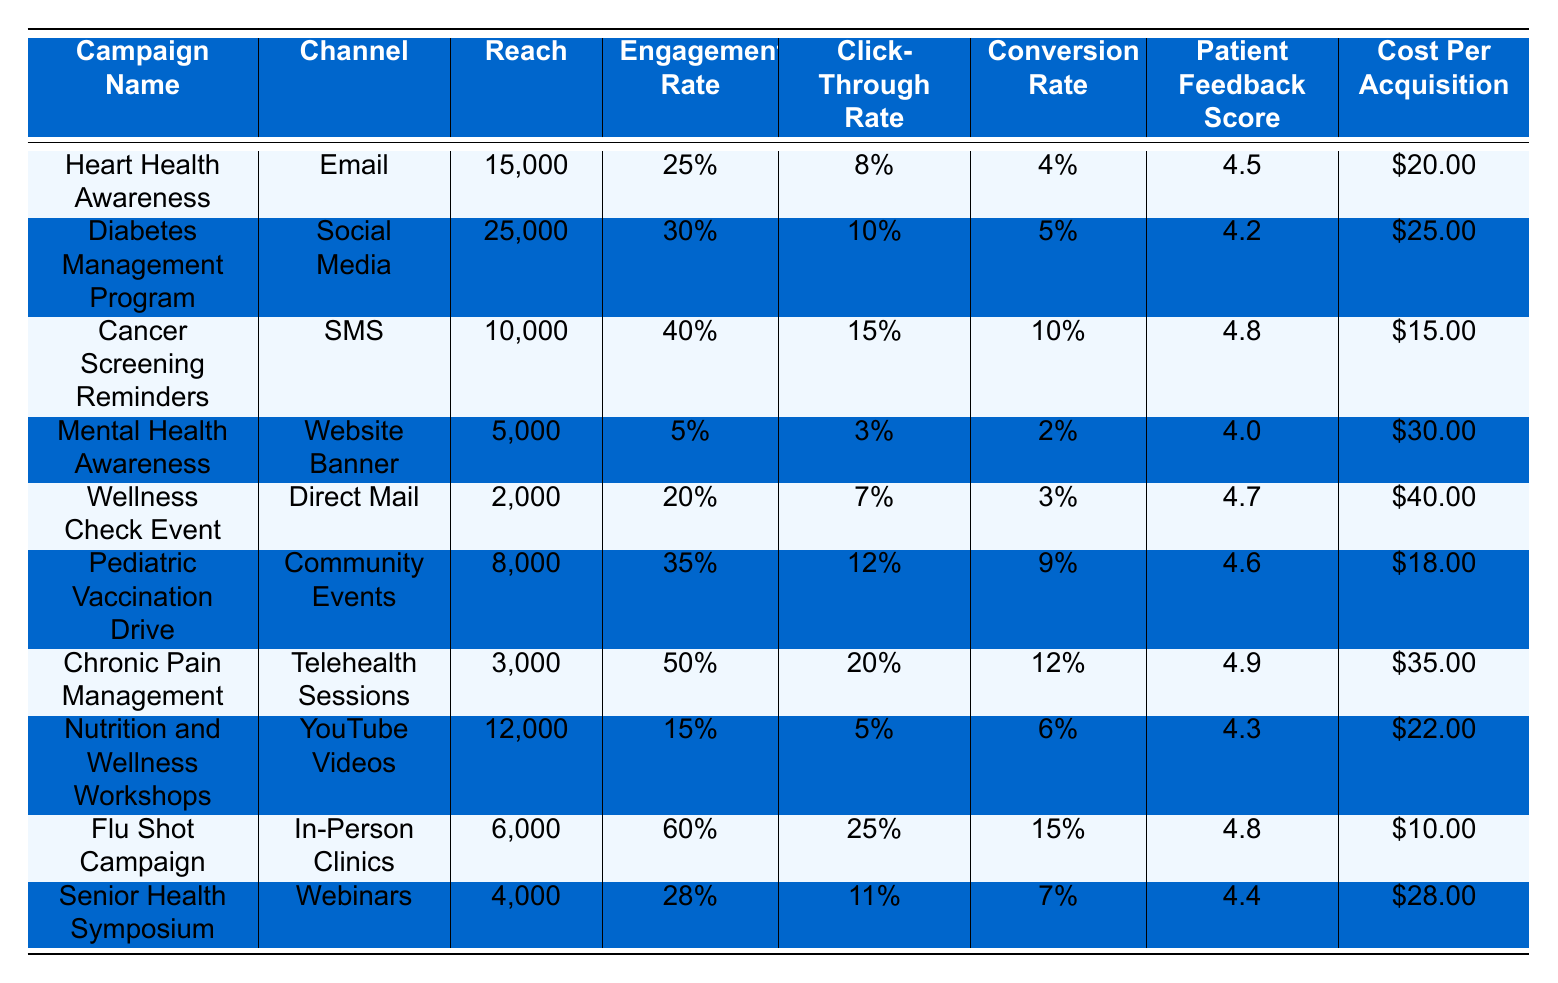What is the channel used for the "Flu Shot Campaign"? The table shows the channel for each campaign; for the "Flu Shot Campaign," the channel is listed as "In-Person Clinics."
Answer: In-Person Clinics Which campaign had the highest cost per acquisition? By comparing the Cost Per Acquisition values in the table, the "Wellness Check Event" has the highest value at $40.00.
Answer: $40.00 What is the engagement rate of the "Nutrition and Wellness Workshops"? The table lists the engagement rate for "Nutrition and Wellness Workshops" as 15%.
Answer: 15% What was the reach for the "Cancer Screening Reminders" campaign? The reach value for "Cancer Screening Reminders" is found directly in the table, which states 10,000.
Answer: 10,000 Which channel achieved the highest click-through rate? The click-through rates for each channel were examined, and the "Flu Shot Campaign" with "In-Person Clinics" has the highest rate at 25%.
Answer: In-Person Clinics What is the average patient feedback score across all campaigns? To find the average, sum all the Patient Feedback Scores (4.5 + 4.2 + 4.8 + 4.0 + 4.7 + 4.6 + 4.9 + 4.3 + 4.8 + 4.4 = 46.2) and divide by the number of campaigns (10); thus, the average is 46.2/10 = 4.62.
Answer: 4.62 Is the engagement rate for the "Mental Health Awareness" campaign greater than 20%? The engagement rate for "Mental Health Awareness" is 5%, which is less than 20%. Therefore, the answer is no.
Answer: No Which campaign had the lowest reach and what was the engagement rate? By inspecting the reach column, "Wellness Check Event" had the lowest reach at 2,000, and its engagement rate is 20%.
Answer: 2,000 and 20% Would you say that SMS campaigns typically have a higher conversion rate than email campaigns based on the table? Examining the conversion rates, SMS campaigns (like "Cancer Screening Reminders" at 10%) have a higher conversion rate than the email campaign (like "Heart Health Awareness" at 4%), confirming that SMS campaigns do seem to perform better.
Answer: Yes What is the difference in cost per acquisition between the "Pediatric Vaccination Drive" and the "Chronic Pain Management" campaigns? The cost per acquisition for "Pediatric Vaccination Drive" is $18.00 and for "Chronic Pain Management" is $35.00. The difference is $35.00 - $18.00 = $17.00.
Answer: $17.00 